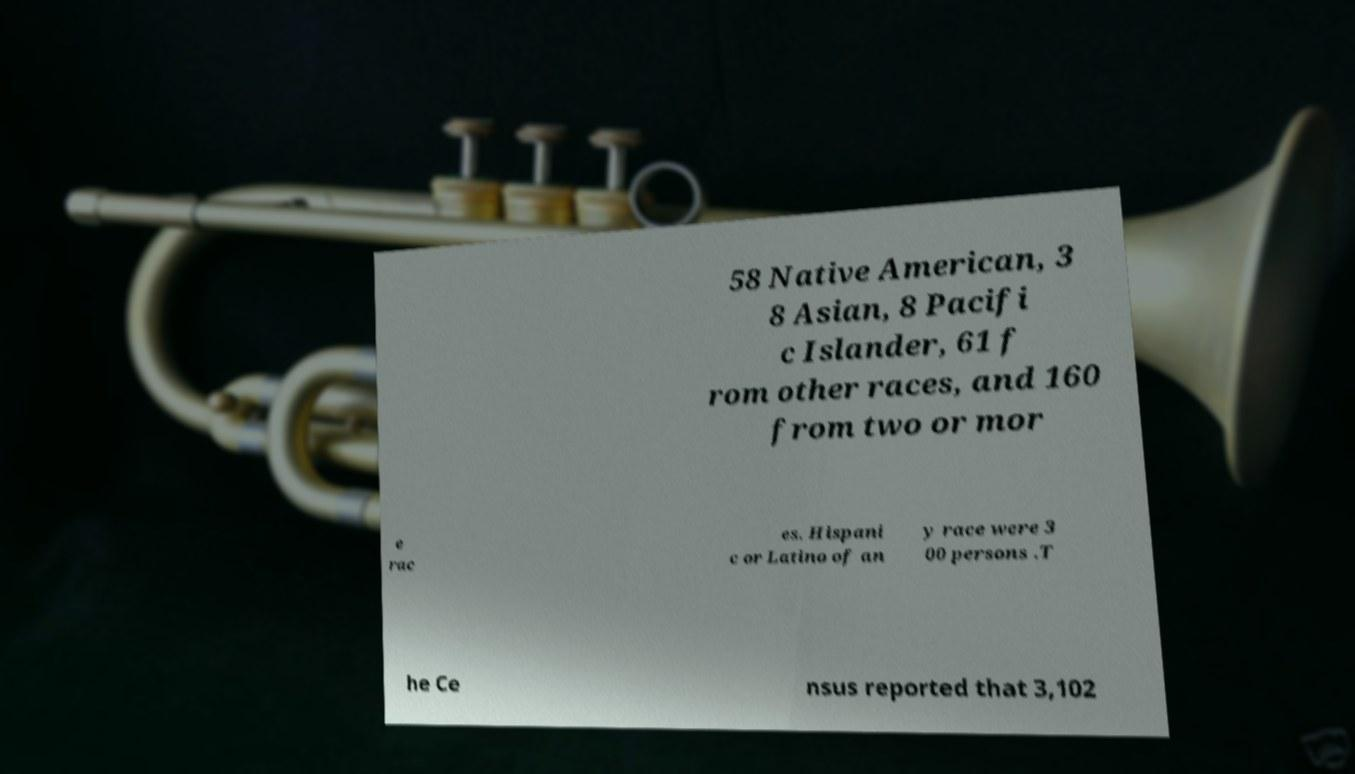What messages or text are displayed in this image? I need them in a readable, typed format. 58 Native American, 3 8 Asian, 8 Pacifi c Islander, 61 f rom other races, and 160 from two or mor e rac es. Hispani c or Latino of an y race were 3 00 persons .T he Ce nsus reported that 3,102 